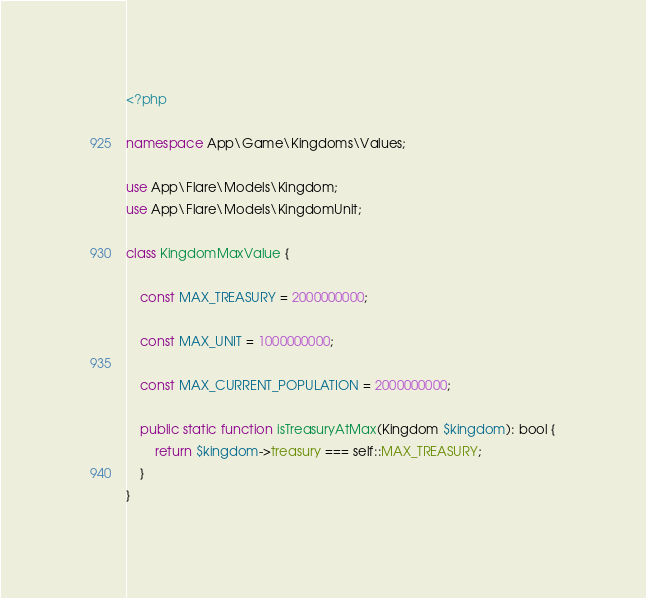<code> <loc_0><loc_0><loc_500><loc_500><_PHP_><?php

namespace App\Game\Kingdoms\Values;

use App\Flare\Models\Kingdom;
use App\Flare\Models\KingdomUnit;

class KingdomMaxValue {

    const MAX_TREASURY = 2000000000;

    const MAX_UNIT = 1000000000;

    const MAX_CURRENT_POPULATION = 2000000000;

    public static function isTreasuryAtMax(Kingdom $kingdom): bool {
        return $kingdom->treasury === self::MAX_TREASURY;
    }
}
</code> 